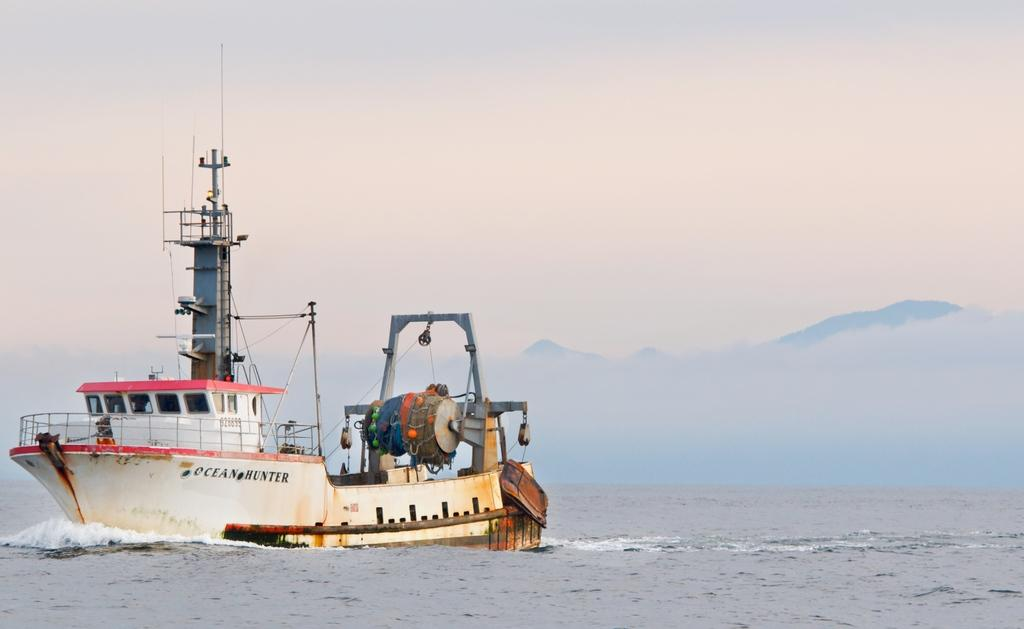What is the main subject of the image? The main subject of the image is a ship. Where is the ship located? The ship is in a water body. What can be seen in the background of the image? There are hills visible in the background of the image. What is the condition of the sky in the image? The sky appears to be cloudy in the image. What type of wine is being served on the ship in the image? There is no indication of wine or any beverage being served on the ship in the image. Can you tell me how many books the people on the ship are reading? There are no people or books visible in the image; it only features a ship in a water body with hills in the background and a cloudy sky. 